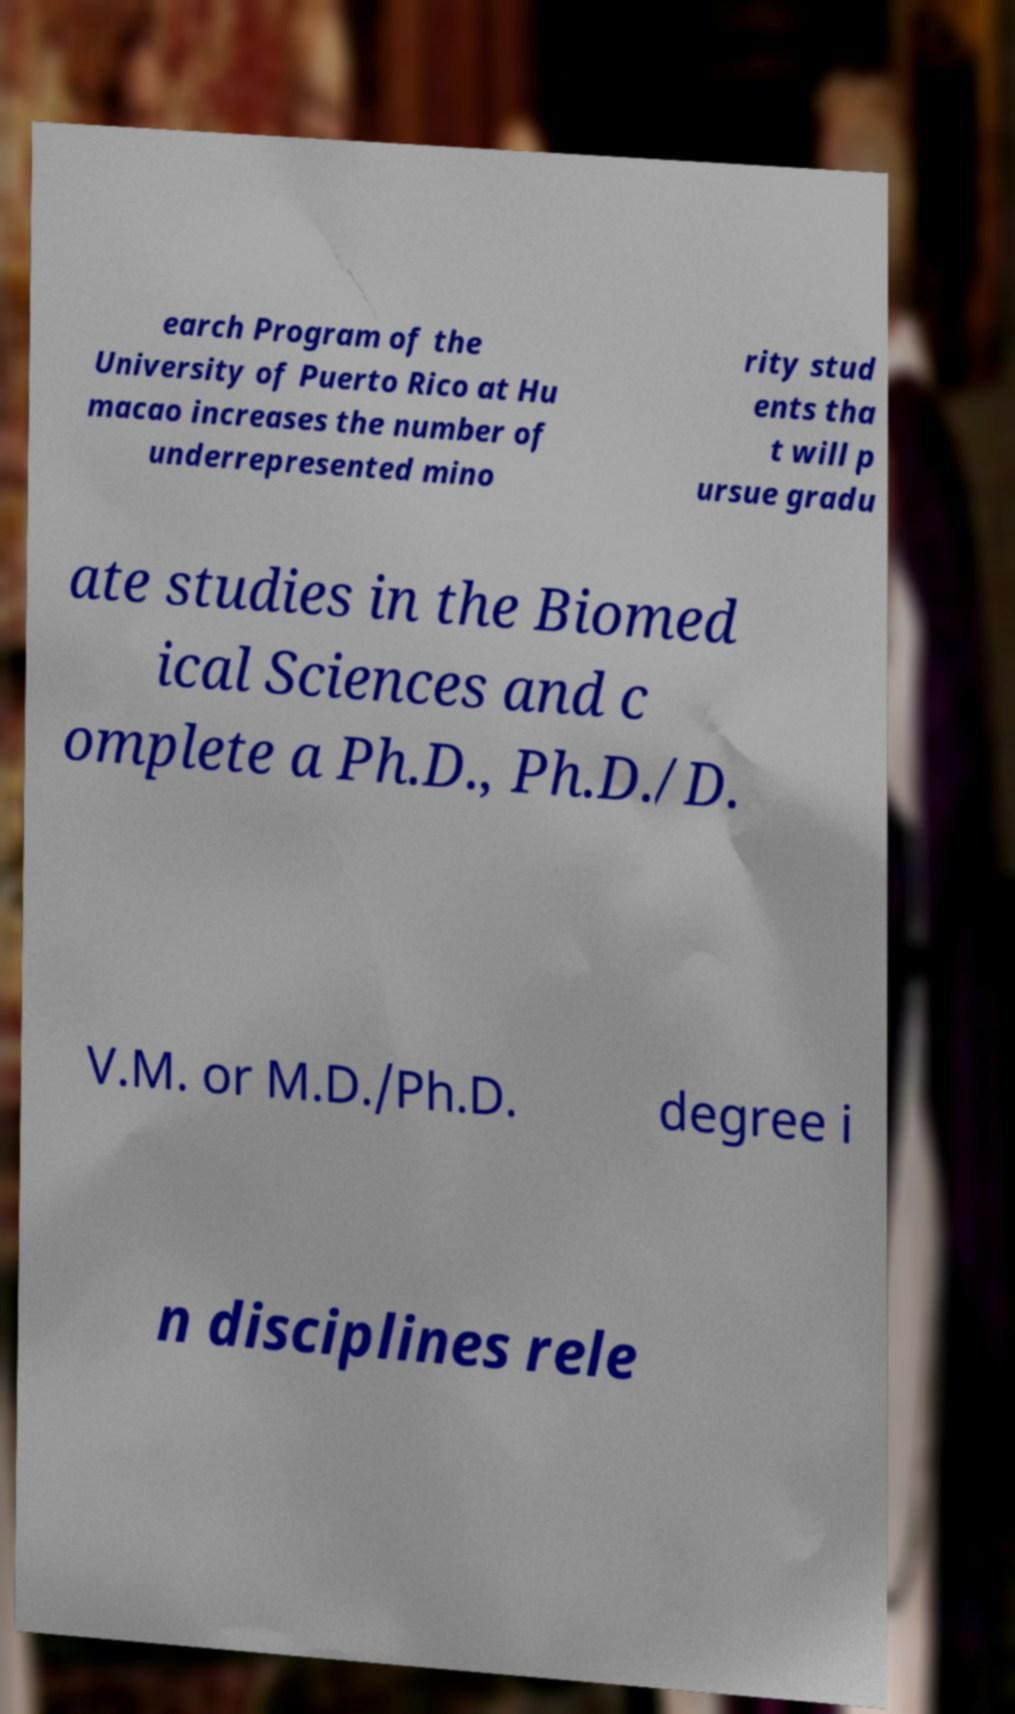Could you assist in decoding the text presented in this image and type it out clearly? earch Program of the University of Puerto Rico at Hu macao increases the number of underrepresented mino rity stud ents tha t will p ursue gradu ate studies in the Biomed ical Sciences and c omplete a Ph.D., Ph.D./D. V.M. or M.D./Ph.D. degree i n disciplines rele 